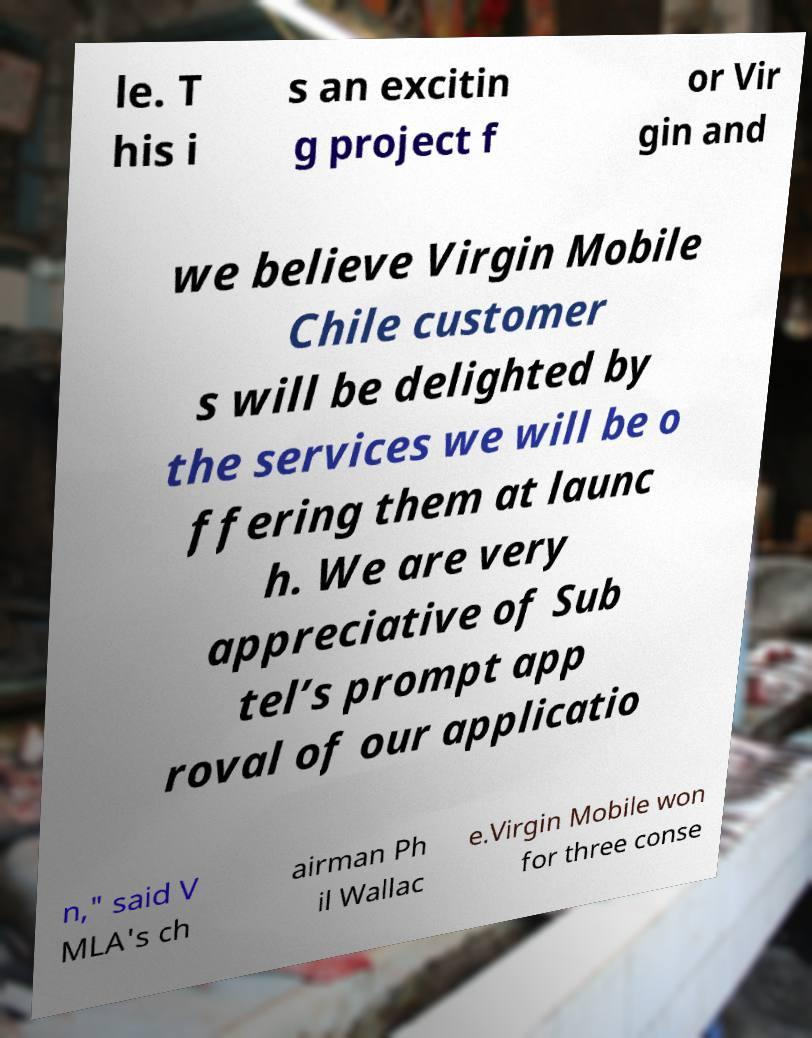Can you read and provide the text displayed in the image?This photo seems to have some interesting text. Can you extract and type it out for me? le. T his i s an excitin g project f or Vir gin and we believe Virgin Mobile Chile customer s will be delighted by the services we will be o ffering them at launc h. We are very appreciative of Sub tel’s prompt app roval of our applicatio n," said V MLA's ch airman Ph il Wallac e.Virgin Mobile won for three conse 